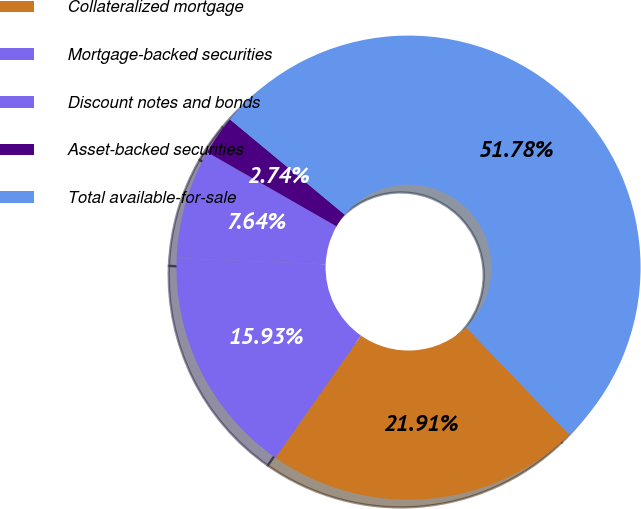Convert chart. <chart><loc_0><loc_0><loc_500><loc_500><pie_chart><fcel>Collateralized mortgage<fcel>Mortgage-backed securities<fcel>Discount notes and bonds<fcel>Asset-backed securities<fcel>Total available-for-sale<nl><fcel>21.91%<fcel>15.93%<fcel>7.64%<fcel>2.74%<fcel>51.78%<nl></chart> 